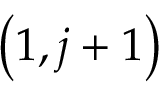<formula> <loc_0><loc_0><loc_500><loc_500>\left ( 1 , j + 1 \right )</formula> 